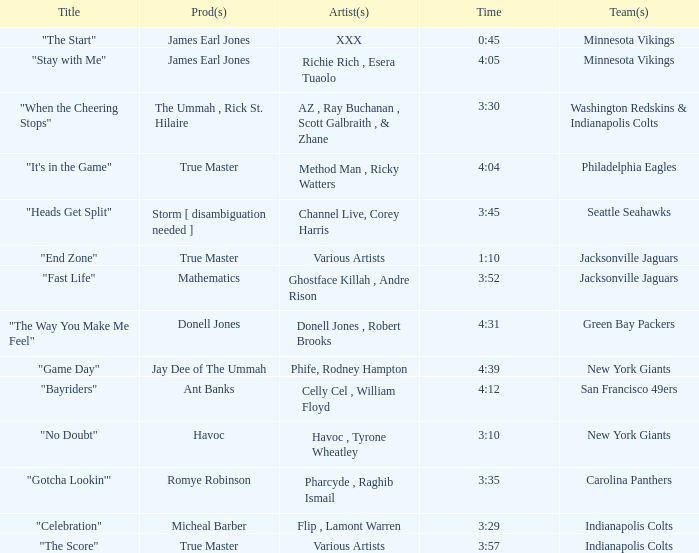Who is the artist of the New York Giants track "No Doubt"? Havoc , Tyrone Wheatley. 